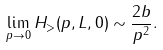<formula> <loc_0><loc_0><loc_500><loc_500>\lim _ { p \rightarrow 0 } H _ { > } ( p , L , 0 ) \sim \frac { 2 b } { p ^ { 2 } } .</formula> 